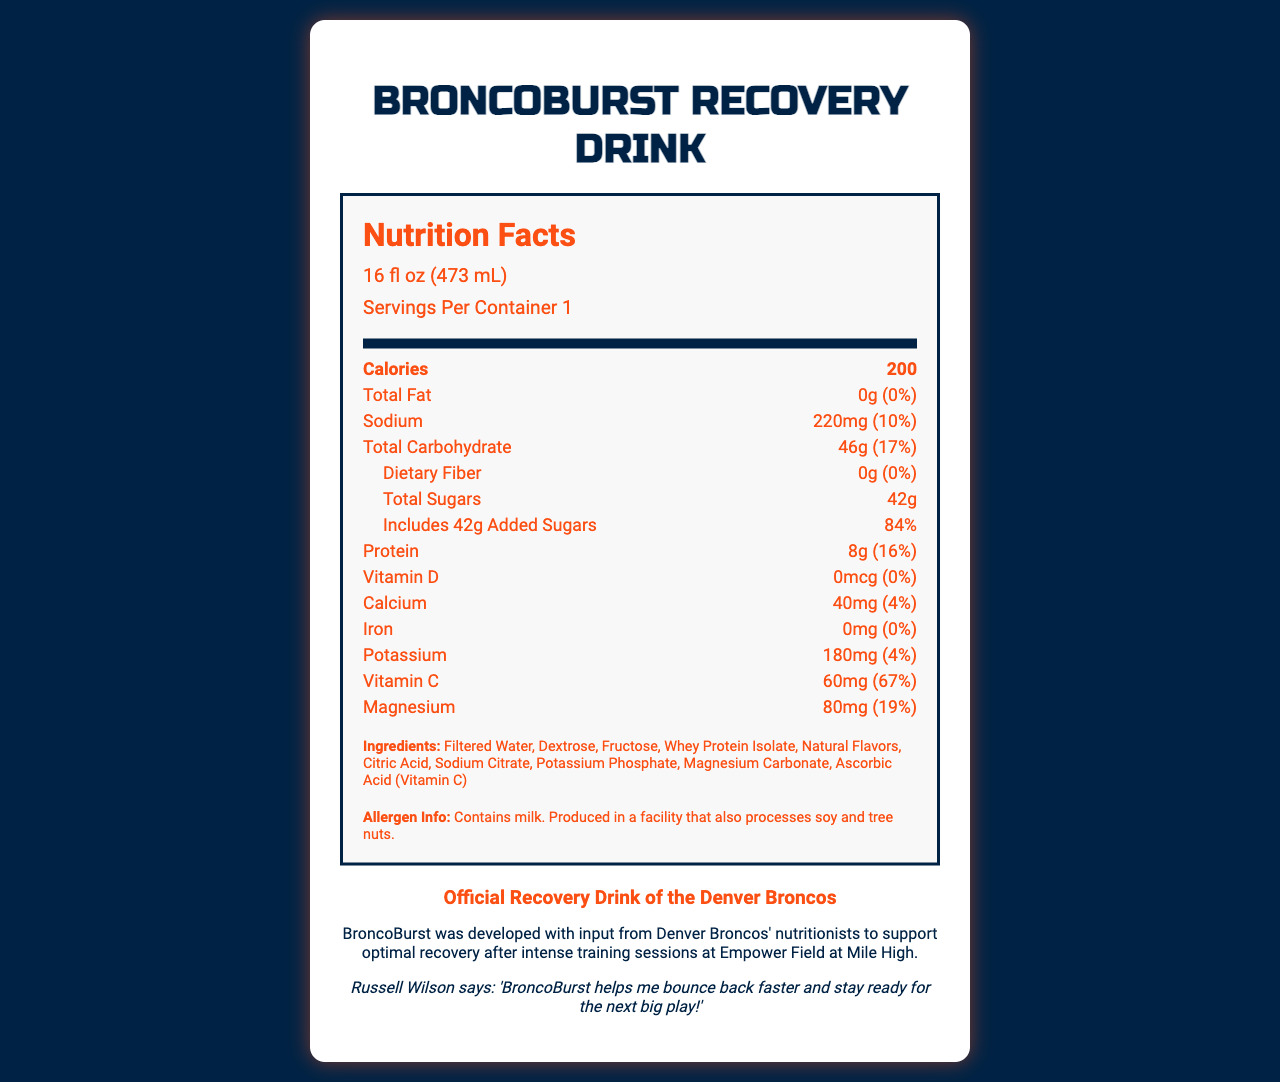who endorses the BroncoBurst Recovery Drink? The endorsement section clearly states "Official Recovery Drink of the Denver Broncos".
Answer: The Denver Broncos what is the serving size of BroncoBurst Recovery Drink? The serving size is listed at the top of the nutrition label as "16 fl oz (473 mL)".
Answer: 16 fl oz (473 mL) what is the amount of protein per serving? Under the nutrient section, it states that the protein content is "8g".
Answer: 8g how many calories are in one serving of BroncoBurst Recovery Drink? It is listed in the document under the "Calories" section.
Answer: 200 calories what is the daily value percentage of added sugars in one serving? The daily value percentage for added sugars is given as "84%" next to the added sugars amount.
Answer: 84% what are the top three ingredients in BroncoBurst Recovery Drink? The ingredients are listed in order, indicating the top three as "Filtered Water, Dextrose, Fructose".
Answer: Filtered Water, Dextrose, Fructose how much sodium does one serving of BroncoBurst Recovery Drink contain? The sodium content is noted as "220mg" in the nutrient section.
Answer: 220mg does BroncoBurst Recovery Drink contain any dietary fiber? The document lists that the drink contains "0g" of dietary fiber.
Answer: No, 0g which nutrient does BroncoBurst Recovery Drink provide the highest daily percentage of? A. Sodium B. Magnesium C. Vitamin C Vitamin C has a daily value percentage of 67%, which is the highest among the listed nutrients.
Answer: C. Vitamin C what is the allergen information for BroncoBurst Recovery Drink? The allergen information section clearly states the presence of milk and potential cross-contamination with soy and tree nuts.
Answer: Contains milk. Produced in a facility that also processes soy and tree nuts. is BroncoBurst Recovery Drink recommended by any Broncos player? The endorsement includes a quote from Russell Wilson saying the drink helps him recover faster.
Answer: Yes why is BroncoBurst developed based on input from Denver Broncos' nutritionists? The fun fact explains that the drink was developed to aid recovery post training.
Answer: To support optimal recovery after intense training sessions at Empower Field at Mile High what are the side effects of drinking too much BroncoBurst? The document does not provide any information about potential side effects of drinking too much BroncoBurst.
Answer: Not enough information summarize the information presented in the document. This explanation covers the structure and key points presented in the document, giving a comprehensive overview.
Answer: The document provides the nutrition facts, ingredient list, and endorsements for BroncoBurst Recovery Drink. It includes detailed nutritional content per 16 fl oz serving, such as 200 calories, 46g of total carbohydrates, 8g of protein, and specific vitamins and minerals. The document also mentions that it is the official recovery drink of the Denver Broncos, endorsed by players like Russell Wilson, and developed with input from team nutritionists. The allergen information states it contains milk and may be cross-contaminated with soy and tree nuts. 